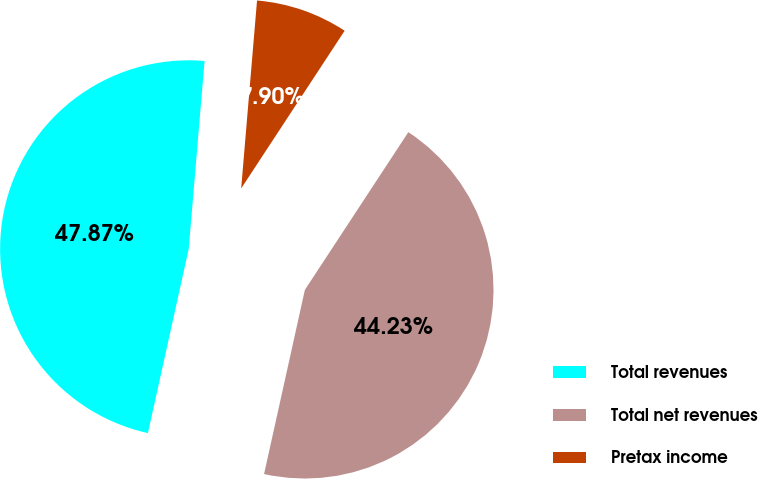Convert chart. <chart><loc_0><loc_0><loc_500><loc_500><pie_chart><fcel>Total revenues<fcel>Total net revenues<fcel>Pretax income<nl><fcel>47.87%<fcel>44.23%<fcel>7.9%<nl></chart> 